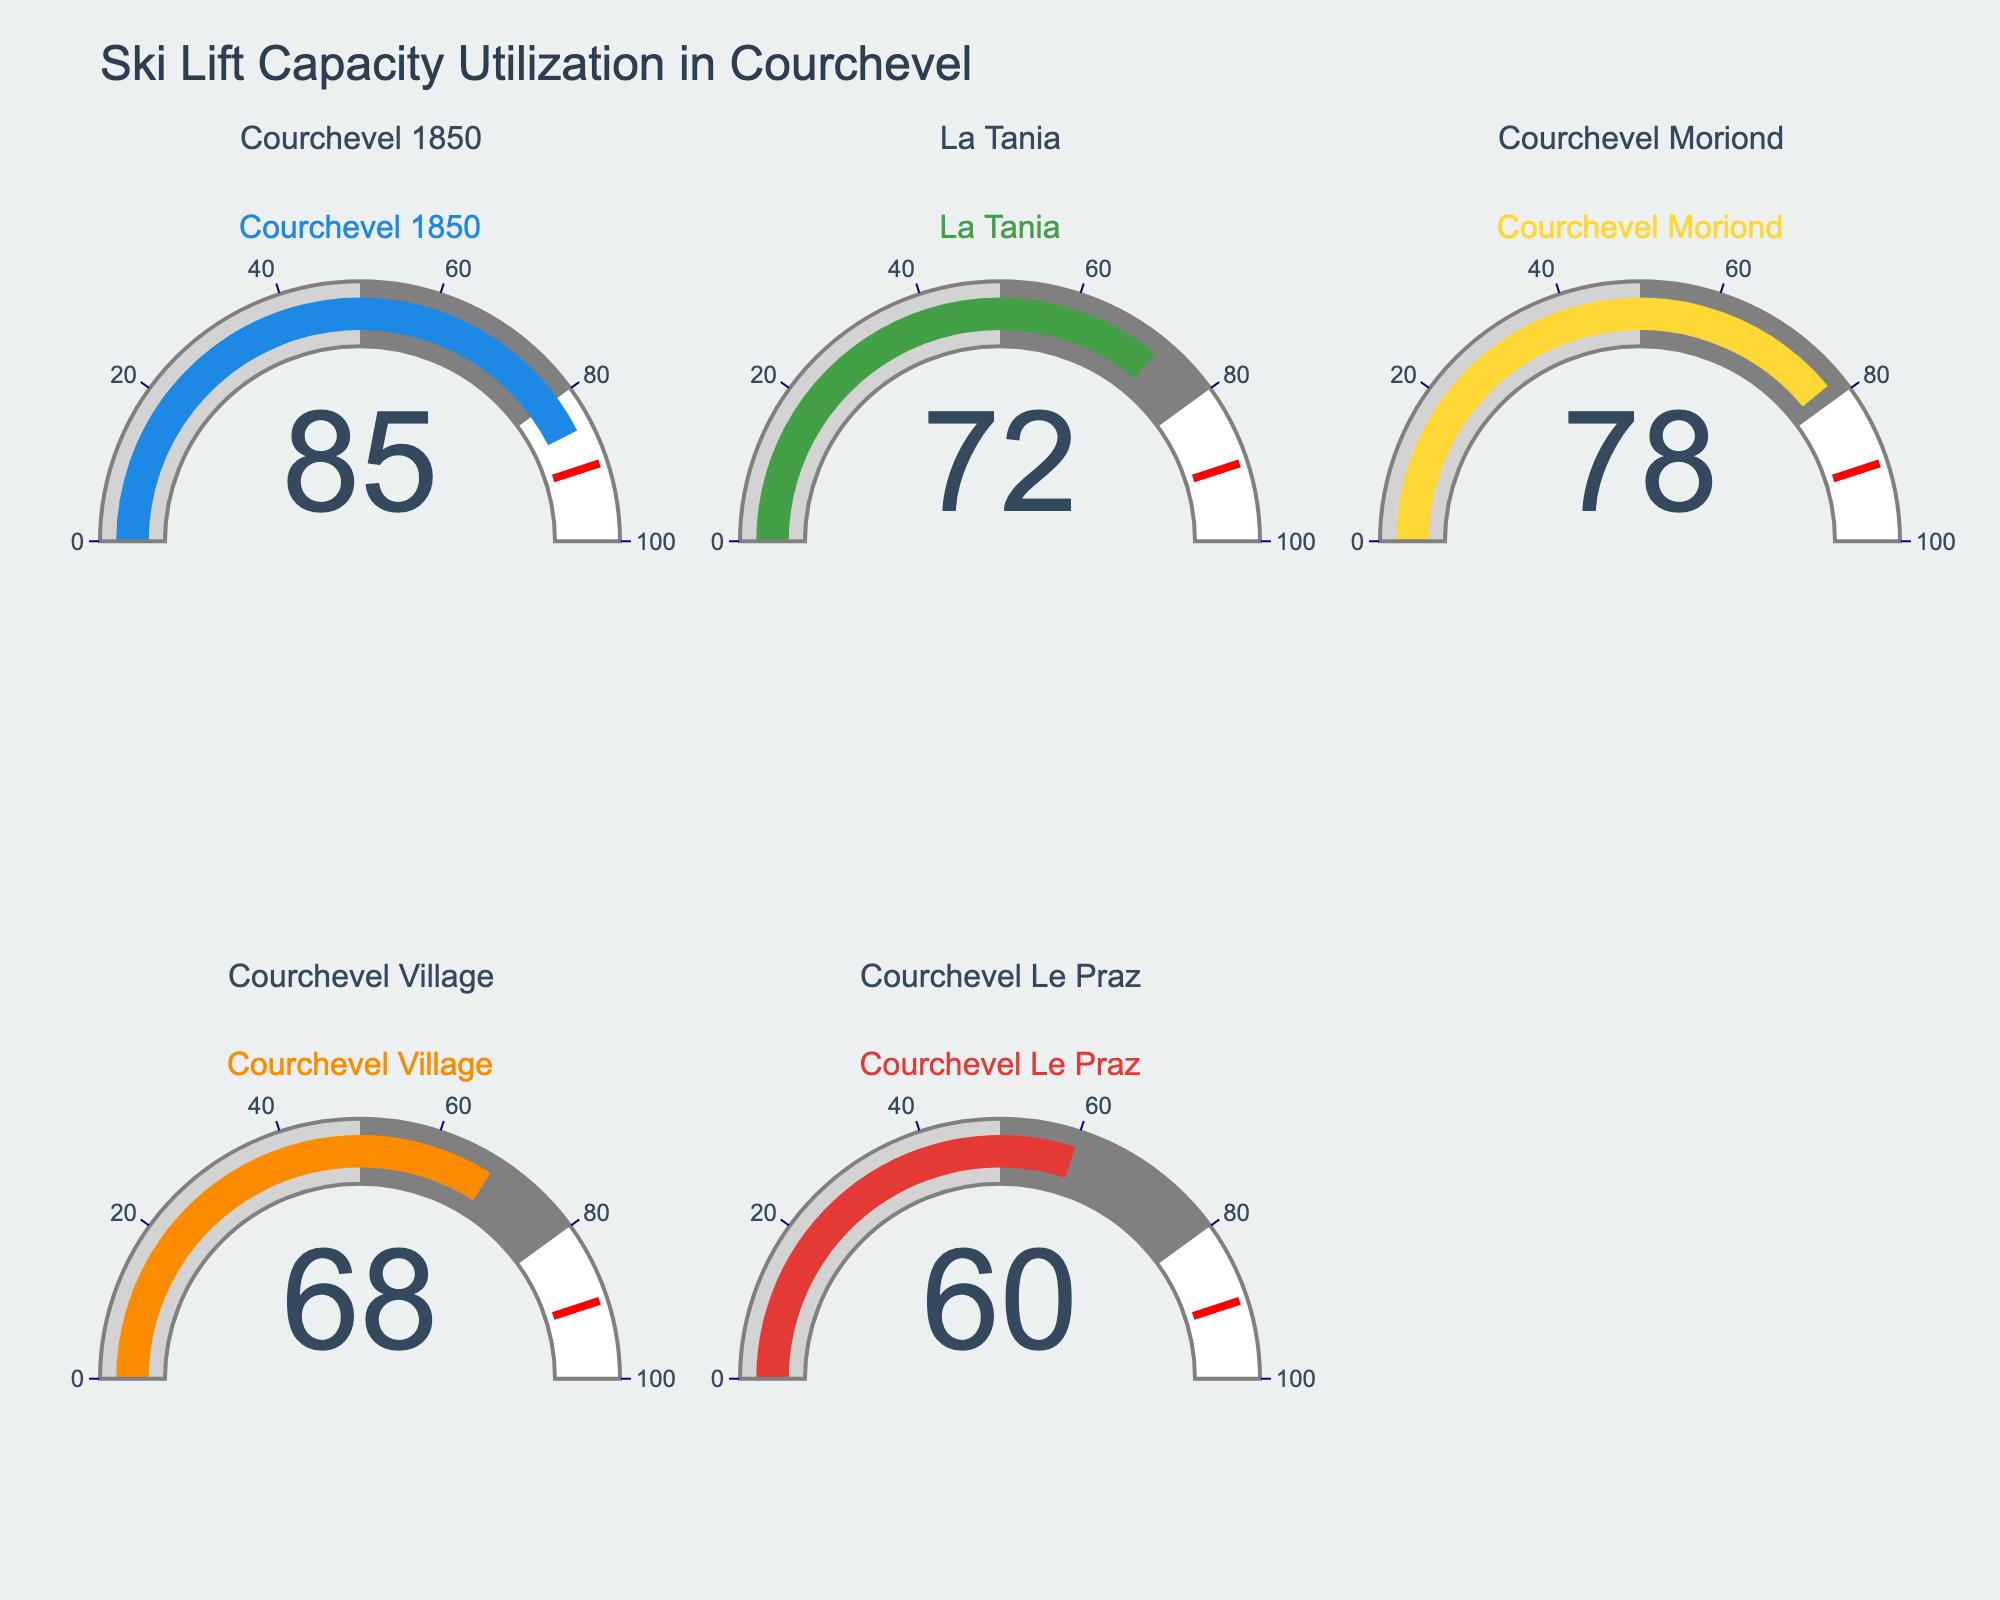What is the title of the figure? The title is typically placed at the top center of the figure. Here, it reads "Ski Lift Capacity Utilization in Courchevel".
Answer: Ski Lift Capacity Utilization in Courchevel Which ski area has the highest lift capacity utilization? The gauge for Courchevel 1850 shows the highest value at 85%.
Answer: Courchevel 1850 What is the lift capacity utilization for Courchevel Le Praz? By looking at the gauge for Courchevel Le Praz, the value displayed is 60%.
Answer: 60% Which ski area has the lowest lift capacity utilization? The gauge for Courchevel Le Praz shows the lowest value at 60%.
Answer: Courchevel Le Praz What is the difference in lift capacity utilization between Courchevel 1850 and La Tania? Subtract the value of La Tania (72) from Courchevel 1850 (85) to get the difference: 85 - 72 = 13.
Answer: 13 What is the average lift capacity utilization of all the ski areas? Sum all the values (85 + 72 + 78 + 68 + 60) and divide by the number of areas. So, (85 + 72 + 78 + 68 + 60) / 5 = 363 / 5 = 72.6.
Answer: 72.6 Are there any areas with lift capacity utilization below 70%? Both Courchevel Village (68%) and Courchevel Le Praz (60%) have values below 70%.
Answer: Yes Which ski areas have lift capacity utilization above 75%? Courchevel 1850 (85%) and Courchevel Moriond (78%) have values above 75%.
Answer: Courchevel 1850, Courchevel Moriond What is the total lift capacity utilization for Courchevel Moriond and Courchevel Village combined? Add the values of Courchevel Moriond (78) and Courchevel Village (68) to get 78 + 68 = 146.
Answer: 146 By how much does Courchevel 1850 exceed Courchevel Le Praz in terms of lift capacity utilization? Subtract the value of Courchevel Le Praz (60) from Courchevel 1850 (85) to get the difference: 85 - 60 = 25.
Answer: 25 